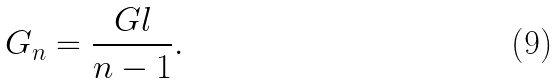<formula> <loc_0><loc_0><loc_500><loc_500>G _ { n } = \frac { G l } { n - 1 } .</formula> 